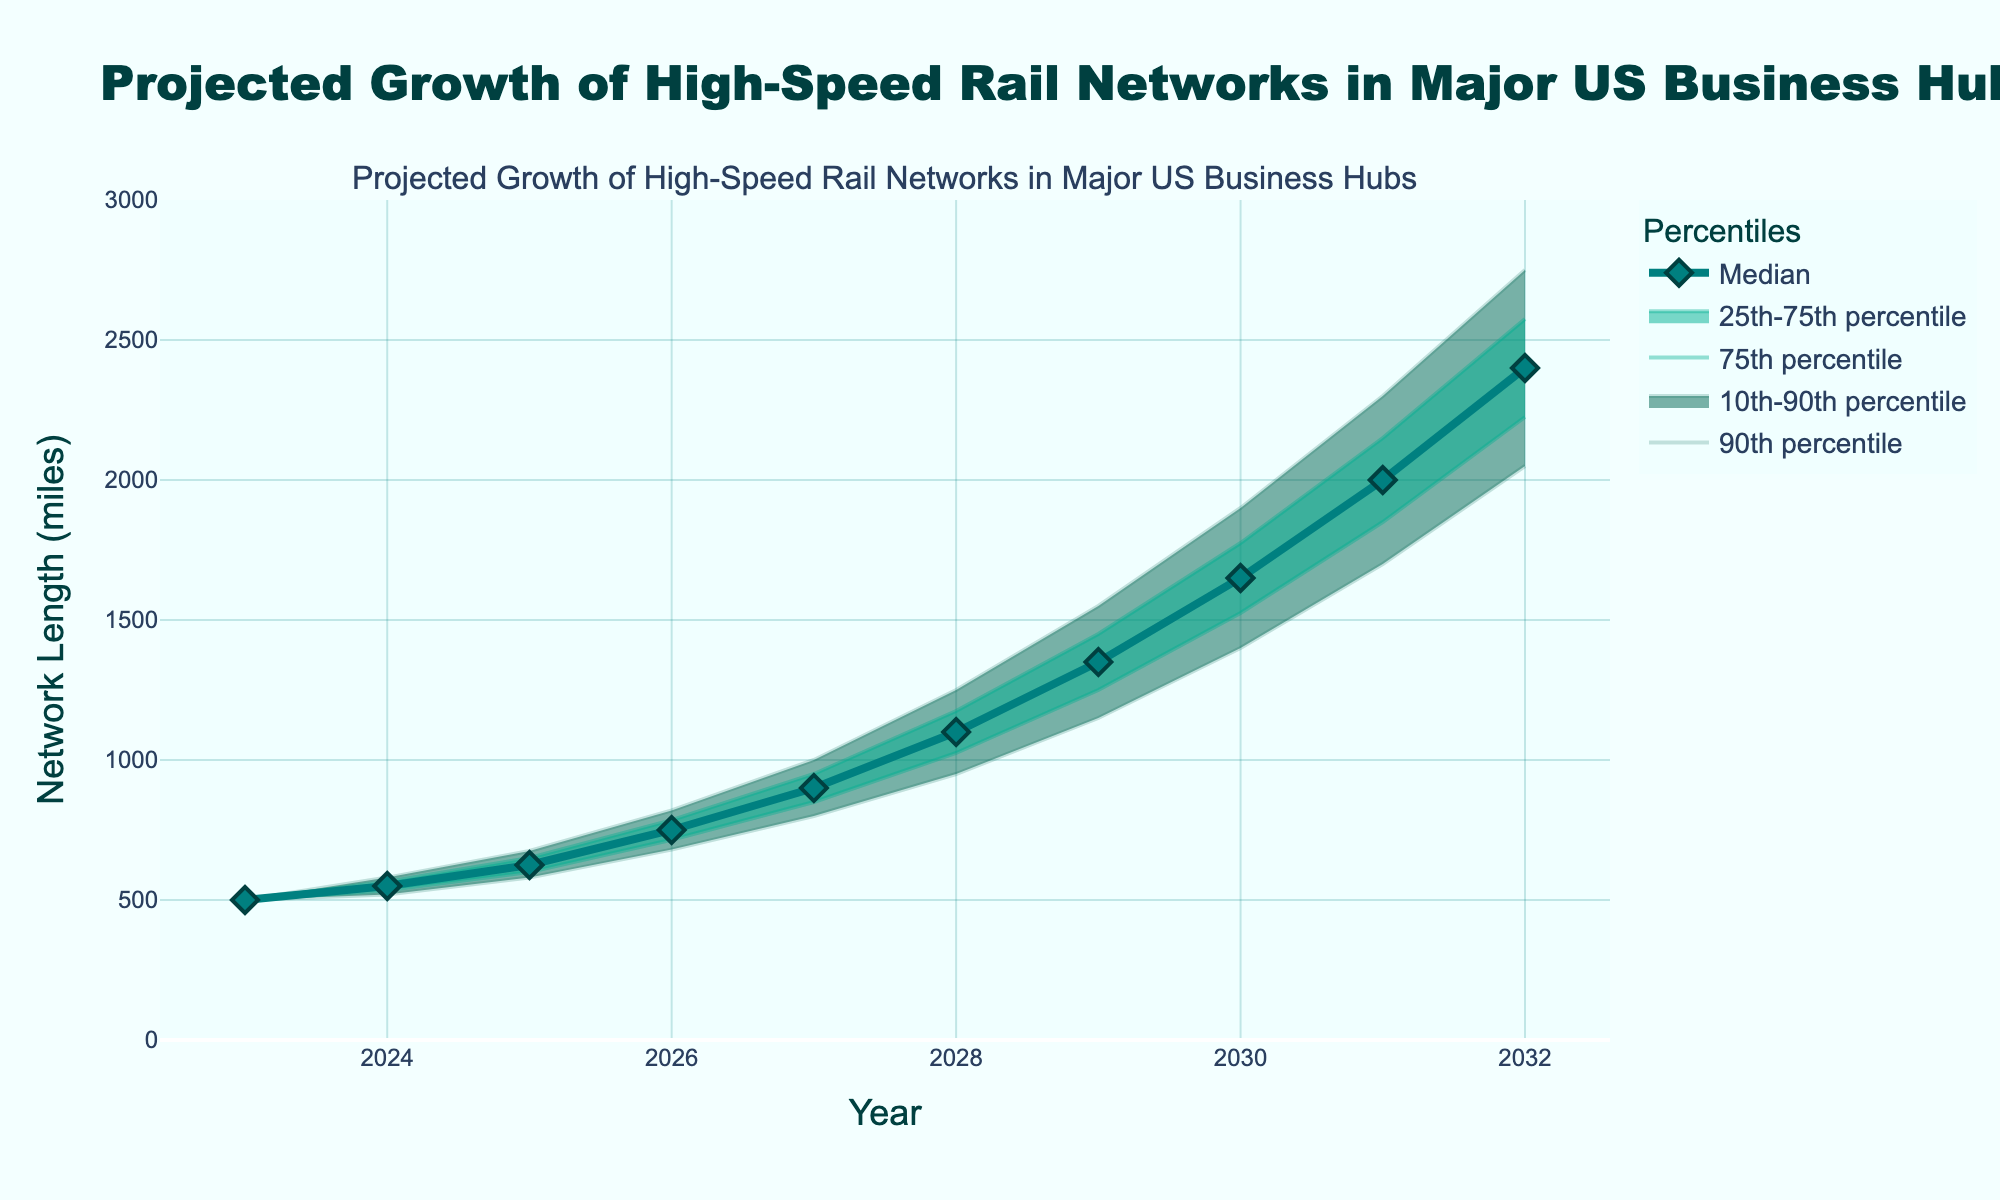What's the title of the figure? The title of the figure is displayed at the top center and reads "Projected Growth of High-Speed Rail Networks in Major US Business Hubs".
Answer: Projected Growth of High-Speed Rail Networks in Major US Business Hubs How many years are projected in this figure? The x-axis labels the years, and the timeline starts at 2023 and ends at 2032. Counting these years gives a total of 10 years.
Answer: 10 What is the median projected length of high-speed rail networks in 2028? The line representing the median value intersects with the year 2028. By following the median line to the y-axis, the value is 1100 miles.
Answer: 1100 miles By how much is the median projected network length expected to increase from 2023 to 2032? The median value in 2023 is 500 miles and in 2032 it is 2400 miles. Subtracting the 2023 value from the 2032 value gives 2400 - 500 = 1900.
Answer: 1900 miles Which year has the highest uncertainty in projected network length? Highest uncertainty is indicated by the widest range between the 10th and 90th percentiles. This is widest in 2032 where the difference is 2750 - 2050 = 700 miles.
Answer: 2032 What's the lower 25th percentile projected network length in 2025? The figure shows the lower 25th percentile value in 2025, which intersects the y-axis at 600 miles.
Answer: 600 miles In which years does the median projected network length cross 1000 miles? The median line crosses the 1000 miles mark between the years 2027 and 2028.
Answer: Between 2027 and 2028 How does the upper 75th percentile trend from 2023 to 2032? The upper 75th percentile line starts at 500 miles in 2023 and steadily increases to 2575 miles by 2032, showing continuous growth.
Answer: Continuous growth Compare the network length's median projection and upper 90th percentile in 2030. Which is greater, and by how much? In 2030, the median is 1650 miles and the upper 90th percentile is 1900 miles. The upper 90th percentile is 1900 - 1650 = 250 miles greater.
Answer: Upper 90th percentile by 250 miles What is the median projected growth rate from 2026 to 2027? The median value in 2026 is 750 miles and in 2027 it increases to 900 miles. The growth rate is (900 - 750) / 750 = 0.2 or 20%.
Answer: 20% 